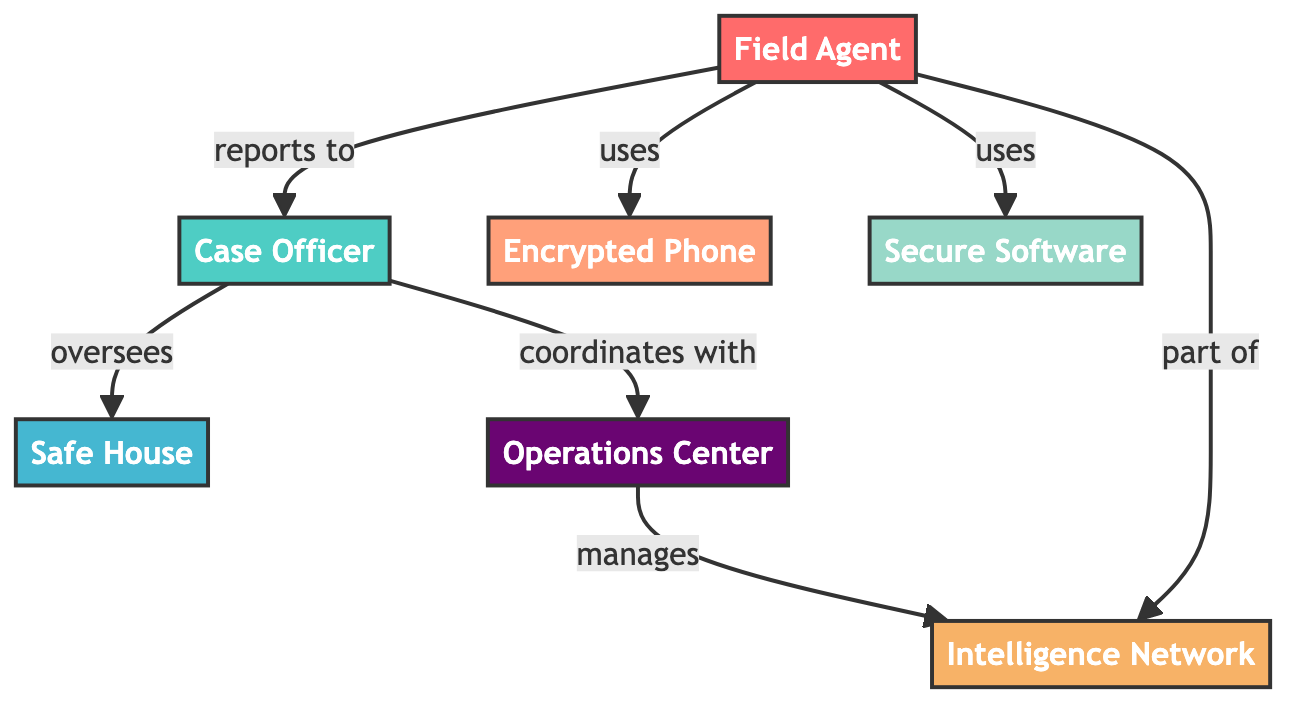What is the total number of nodes in the diagram? The diagram lists seven distinct nodes: Field Agent, Case Officer, Safe House, Encrypted Phone, Secure Software, Intelligence Network, and Operations Center. Counting these, the total number of nodes is seven.
Answer: seven Which node is a device for secure communication? The node labeled "Encrypted Phone" is described as a device for secure voice and text communication. It is specifically categorized as equipment within the diagram.
Answer: Encrypted Phone What is the relationship between the Field Agent and the Case Officer? The diagram shows an arrow from the Field Agent to the Case Officer labeled "reports to," indicating that the Field Agent is under the direct supervision of the Case Officer.
Answer: reports to Who coordinates with the Operations Center? The arrow indicates that the Case Officer coordinates with the Operations Center. This relationship is specified in the diagram as "coordinates with."
Answer: Case Officer How many edges are present in the diagram? There are six distinct edges in the diagram, connecting pairs of nodes with different relationships, forming the communication structure in the network.
Answer: six What does the Safe House node represent? According to the description in the diagram, the Safe House is a secure location for meetings and transfer of information, categorized as a station.
Answer: secure location for meetings Which node is part of the Intelligence Network? The diagram indicates that the Field Agent is a part of the Intelligence Network, as shown by the arrow linking these two nodes with the relationship labeled "part of."
Answer: Field Agent How does the Operations Center relate to the Intelligence Network? The diagram shows that the Operations Center manages the Intelligence Network, as indicated by the arrow connecting these two nodes labeled "manages."
Answer: manages What type of node is the Secure Software? The Secure Software is classified as technology in the diagram. It is specifically described as a suite of tools for encrypting and decrypting messages.
Answer: technology 